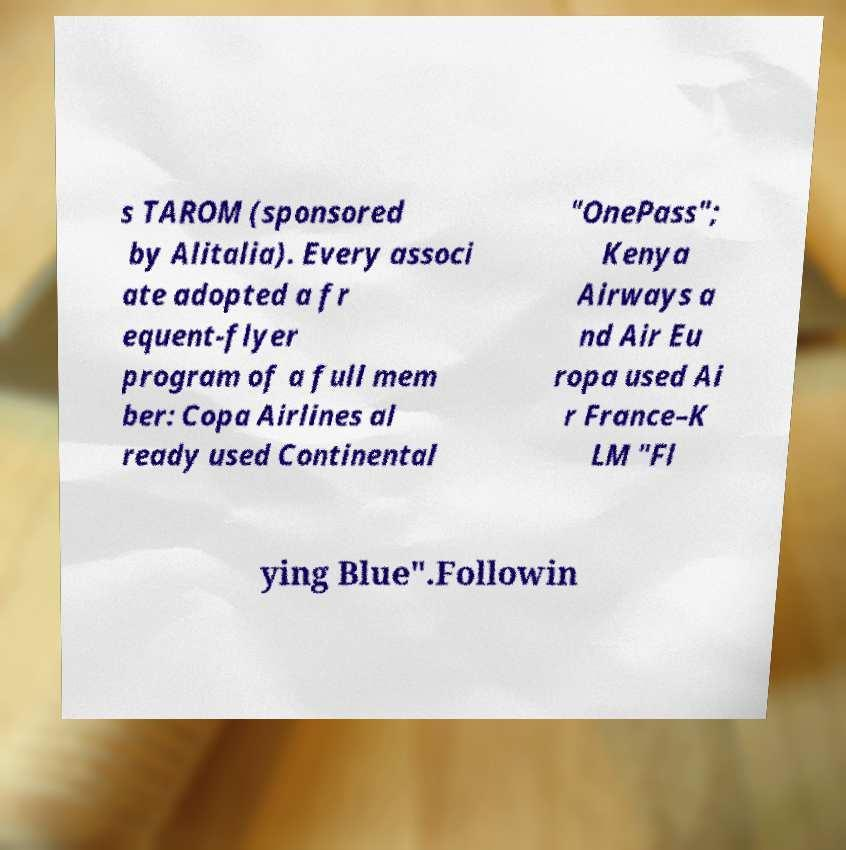Could you assist in decoding the text presented in this image and type it out clearly? s TAROM (sponsored by Alitalia). Every associ ate adopted a fr equent-flyer program of a full mem ber: Copa Airlines al ready used Continental "OnePass"; Kenya Airways a nd Air Eu ropa used Ai r France–K LM "Fl ying Blue".Followin 